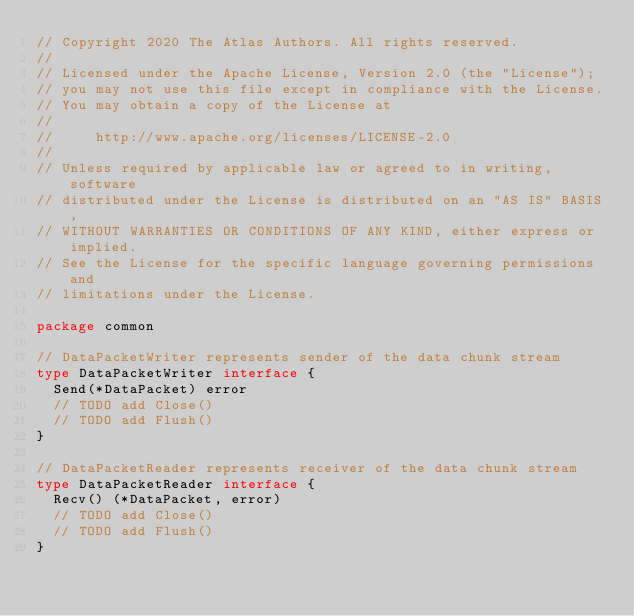Convert code to text. <code><loc_0><loc_0><loc_500><loc_500><_Go_>// Copyright 2020 The Atlas Authors. All rights reserved.
//
// Licensed under the Apache License, Version 2.0 (the "License");
// you may not use this file except in compliance with the License.
// You may obtain a copy of the License at
//
//     http://www.apache.org/licenses/LICENSE-2.0
//
// Unless required by applicable law or agreed to in writing, software
// distributed under the License is distributed on an "AS IS" BASIS,
// WITHOUT WARRANTIES OR CONDITIONS OF ANY KIND, either express or implied.
// See the License for the specific language governing permissions and
// limitations under the License.

package common

// DataPacketWriter represents sender of the data chunk stream
type DataPacketWriter interface {
	Send(*DataPacket) error
	// TODO add Close()
	// TODO add Flush()
}

// DataPacketReader represents receiver of the data chunk stream
type DataPacketReader interface {
	Recv() (*DataPacket, error)
	// TODO add Close()
	// TODO add Flush()
}
</code> 